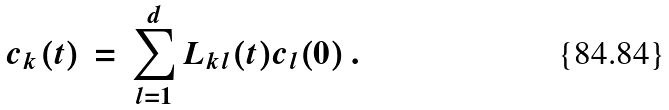<formula> <loc_0><loc_0><loc_500><loc_500>c _ { k } ( t ) \, = \, \sum _ { l = 1 } ^ { d } L _ { k l } ( t ) c _ { l } ( 0 ) \, .</formula> 